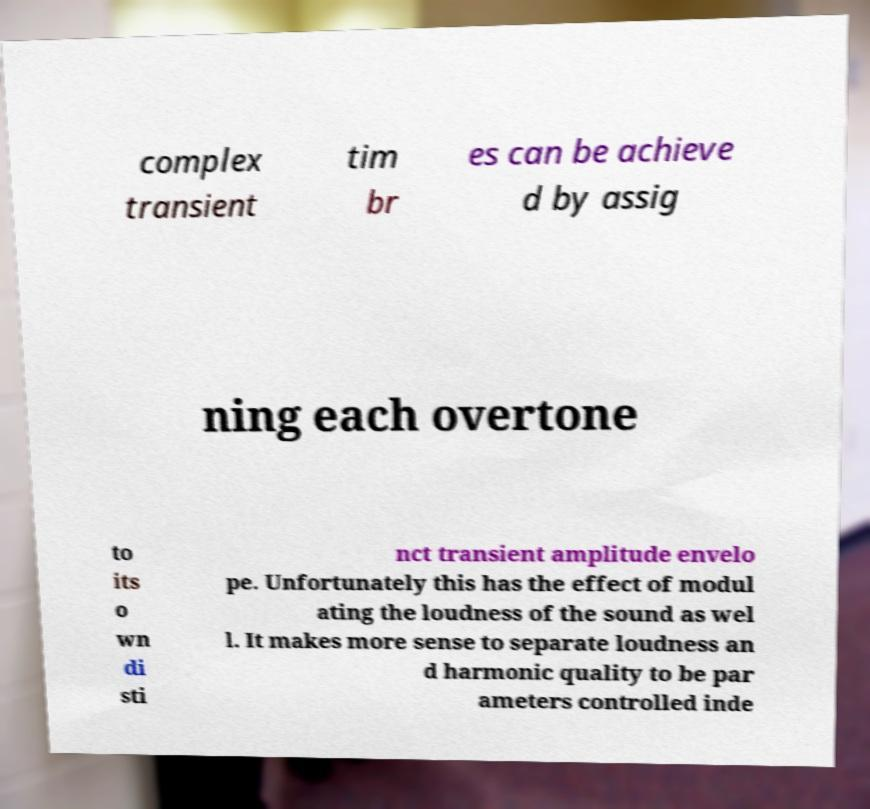Can you accurately transcribe the text from the provided image for me? complex transient tim br es can be achieve d by assig ning each overtone to its o wn di sti nct transient amplitude envelo pe. Unfortunately this has the effect of modul ating the loudness of the sound as wel l. It makes more sense to separate loudness an d harmonic quality to be par ameters controlled inde 